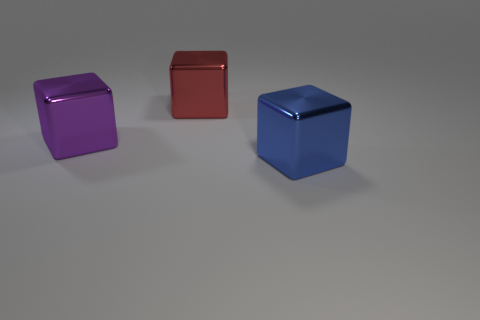The large purple metal thing is what shape?
Your answer should be very brief. Cube. Are there more red shiny objects in front of the big red object than big yellow blocks?
Keep it short and to the point. No. There is a blue object; is it the same shape as the purple object that is to the left of the large red metallic object?
Offer a very short reply. Yes. Are there any large blue matte things?
Your response must be concise. No. What number of tiny objects are either blue metal cubes or purple objects?
Your response must be concise. 0. Are there more big shiny objects left of the large purple object than large purple shiny objects behind the large blue cube?
Give a very brief answer. No. Does the big red object have the same material as the large cube in front of the purple block?
Your answer should be compact. Yes. The thing that is behind the purple metallic object has what shape?
Your answer should be compact. Cube. How many gray objects are either big cylinders or big cubes?
Your answer should be compact. 0. What color is the metallic block that is both in front of the red metallic cube and behind the blue block?
Give a very brief answer. Purple. 